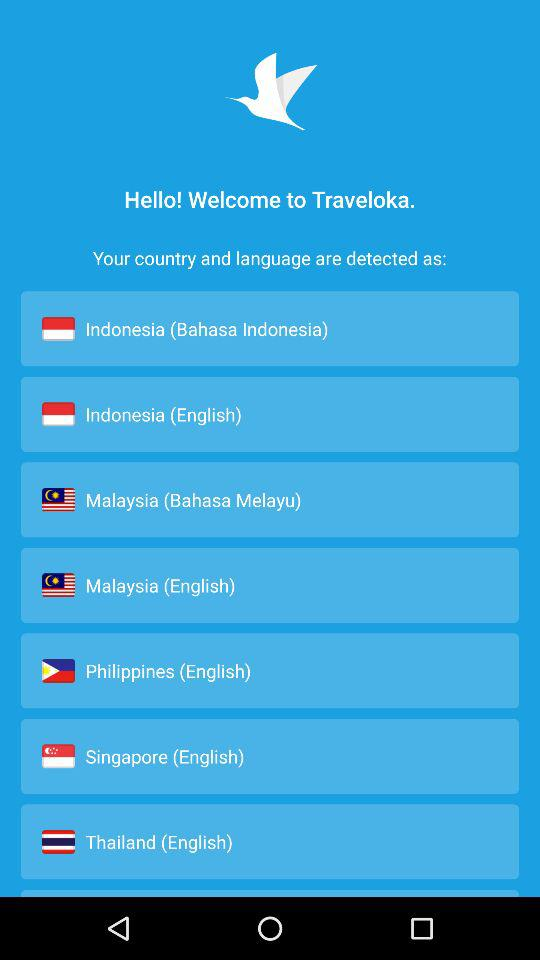What is the language of the Philippines? The language of the Philippines is English. 